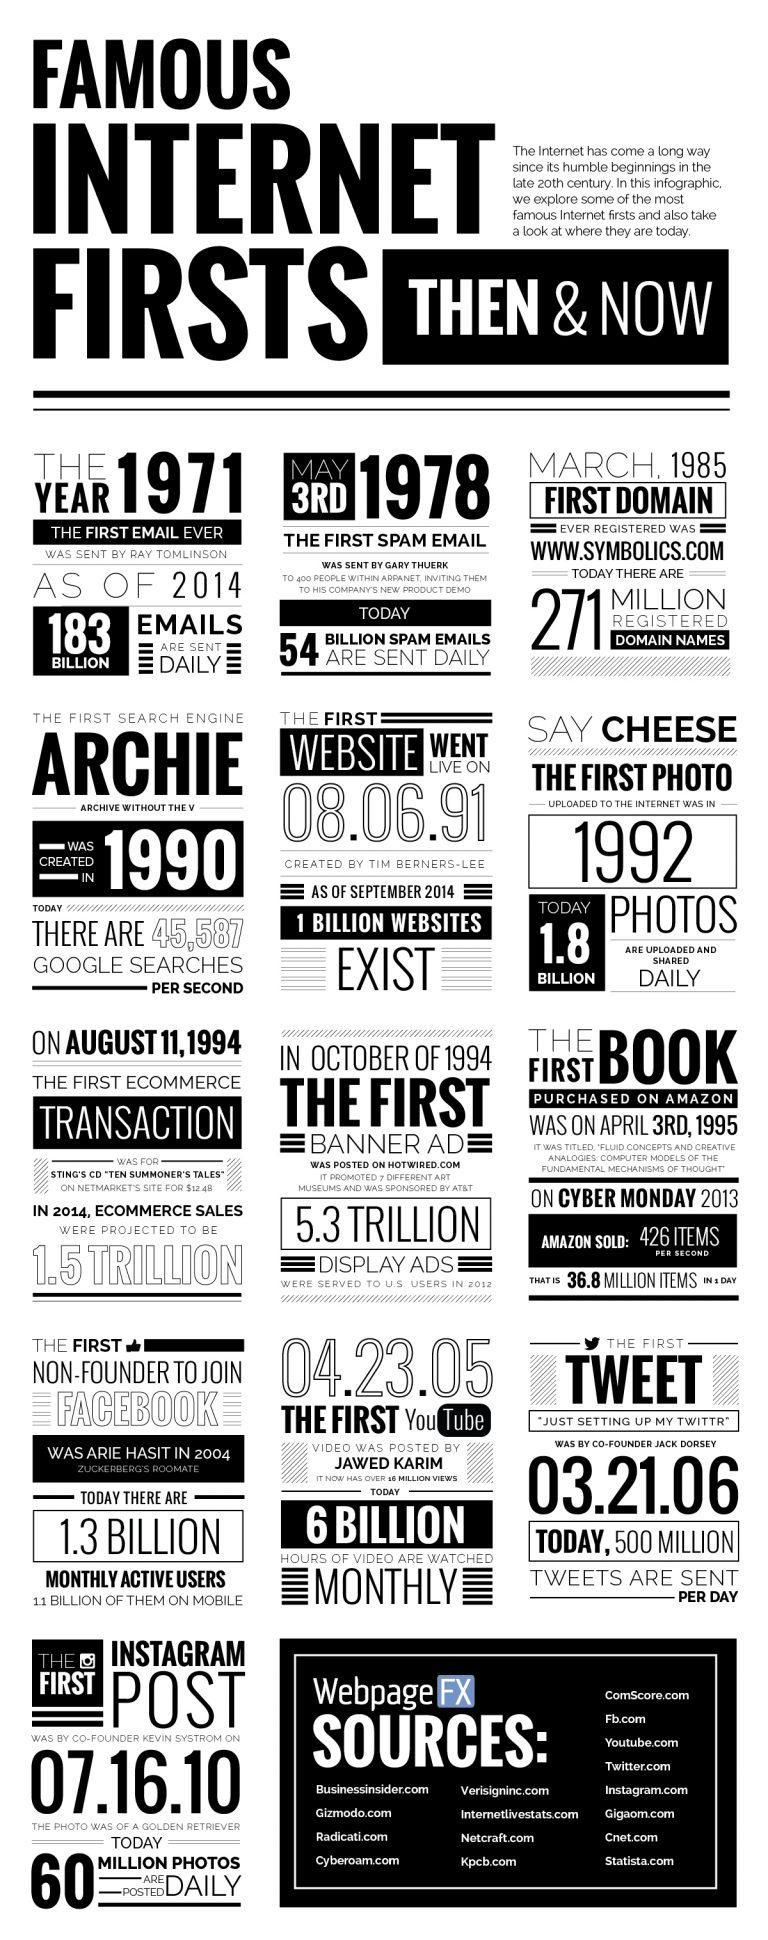How many views for the first youtube video?
Answer the question with a short phrase. 16 million What is the name of the person who posted the first youtube video? Jawed Karim In which year first photo uploaded to the internet? 1992 What is the name of the person who made the first tweet? Jack Dorsey What was the first tweet? Just setting up my twittr What is the name of the person who sent the first spam email? Gary Thuerk 